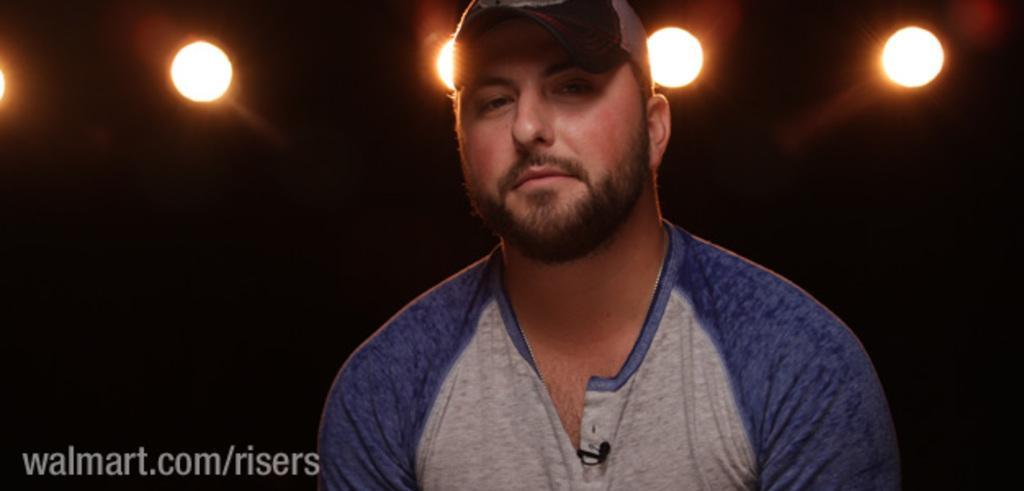How would you summarize this image in a sentence or two? In this image we can see a person wearing a cap and the background is dark, also we can see some lights, at the bottom of the image we can see some text. 